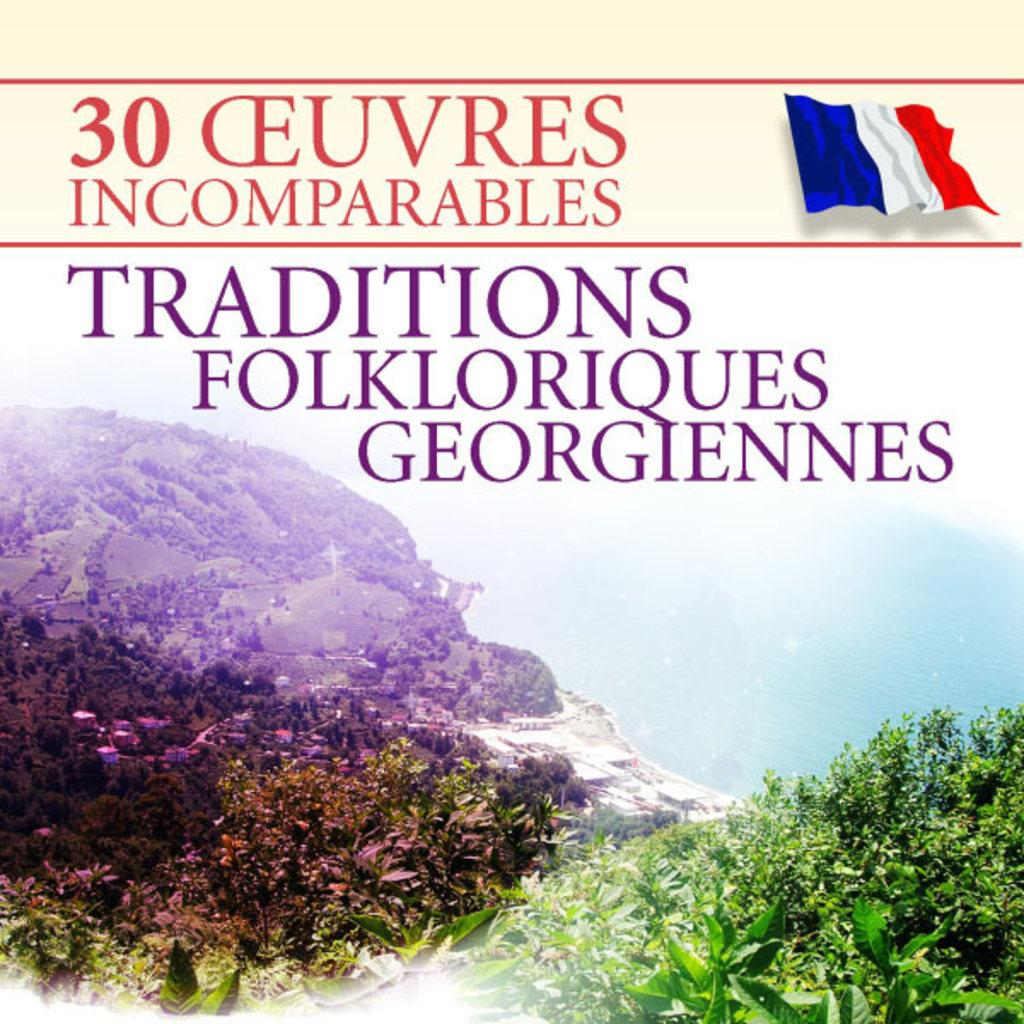Provide a one-sentence caption for the provided image. A book to do with French traditions and folklores. 